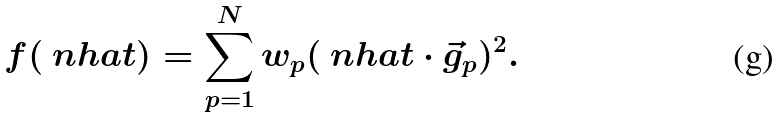Convert formula to latex. <formula><loc_0><loc_0><loc_500><loc_500>f ( \ n h a t ) = \sum _ { p = 1 } ^ { N } w _ { p } ( \ n h a t \cdot \vec { g } _ { p } ) ^ { 2 } .</formula> 